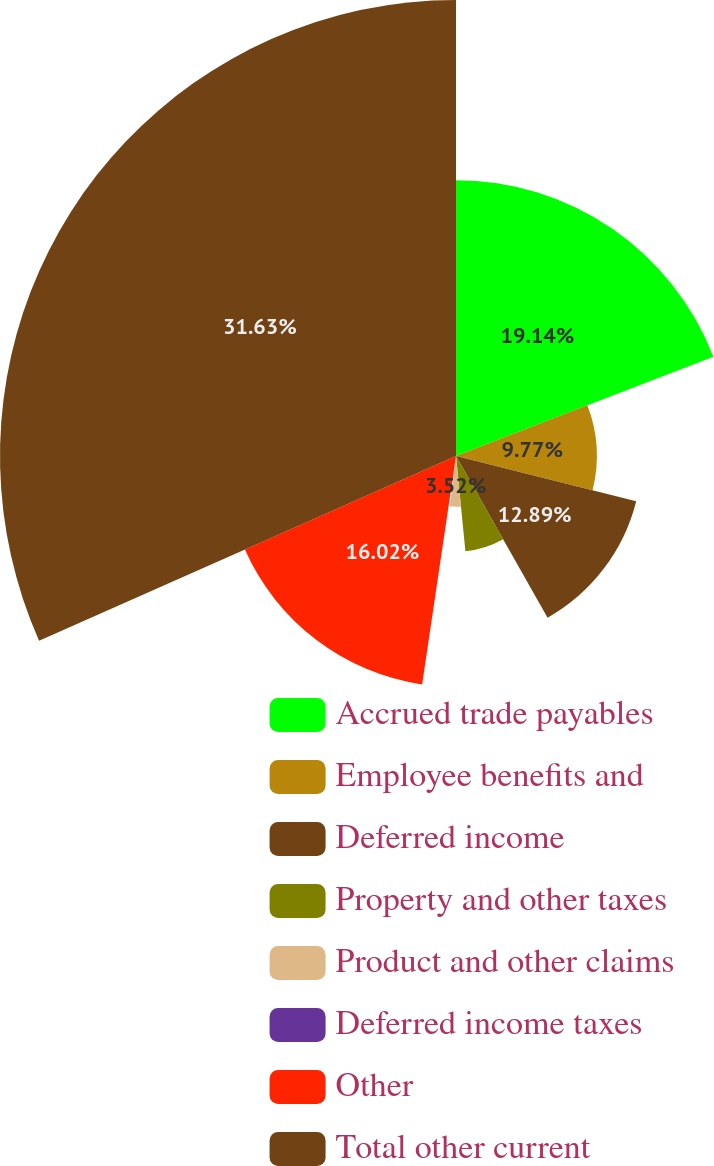Convert chart. <chart><loc_0><loc_0><loc_500><loc_500><pie_chart><fcel>Accrued trade payables<fcel>Employee benefits and<fcel>Deferred income<fcel>Property and other taxes<fcel>Product and other claims<fcel>Deferred income taxes<fcel>Other<fcel>Total other current<nl><fcel>19.14%<fcel>9.77%<fcel>12.89%<fcel>6.64%<fcel>3.52%<fcel>0.39%<fcel>16.02%<fcel>31.64%<nl></chart> 